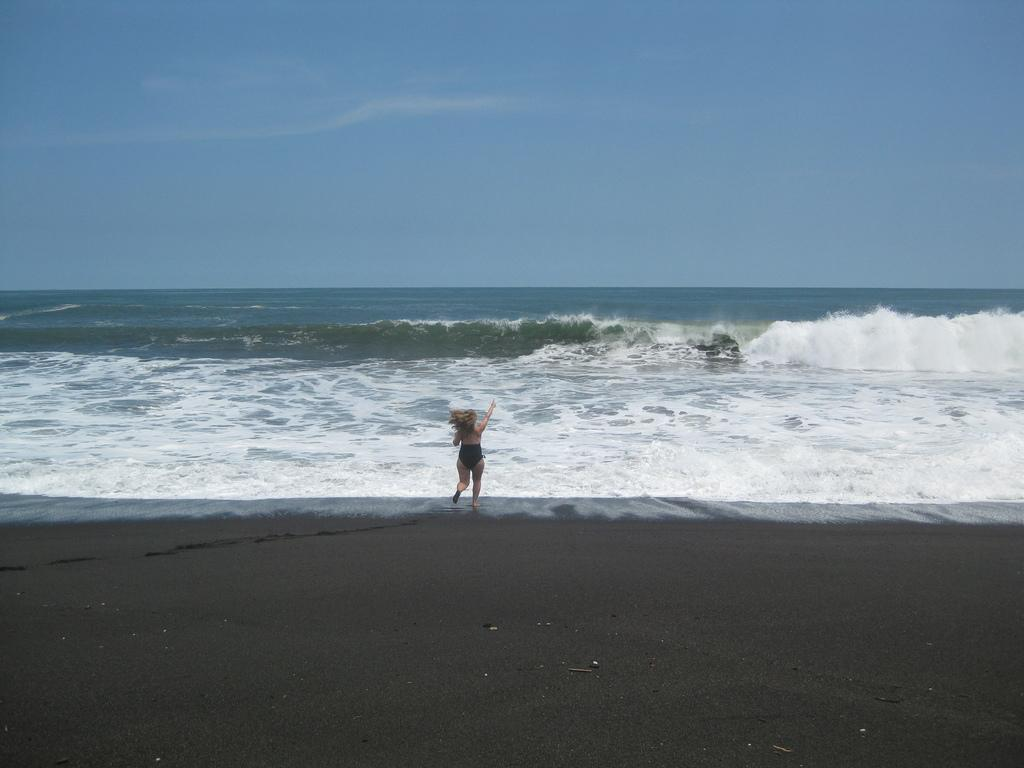Who is the main subject in the image? There is a woman in the middle of the image. What can be seen in the background of the image? Water and clouds are visible in the background of the image. What type of gold line can be seen connecting the woman to the clouds in the image? There is no gold line connecting the woman to the clouds in the image; it is a simple image of a woman with water and clouds in the background. 